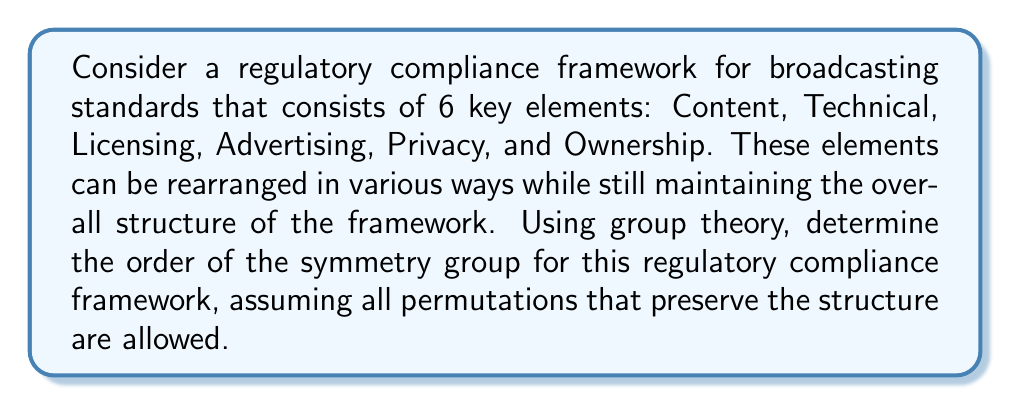Could you help me with this problem? To analyze the symmetry group of this regulatory compliance framework using group theory, we need to consider the permutations that preserve its structure. In this case, since all elements can be rearranged without changing the overall framework, we are dealing with the symmetric group on 6 elements, denoted as $S_6$.

The order of a symmetric group $S_n$ is given by $n!$, where $n$ is the number of elements being permuted. In this case, we have 6 elements, so:

1. Identify the number of elements: $n = 6$

2. Calculate the order of the symmetry group:
   $$|S_6| = 6!$$

3. Expand the factorial:
   $$6! = 6 \times 5 \times 4 \times 3 \times 2 \times 1$$

4. Compute the final result:
   $$6! = 720$$

Therefore, the order of the symmetry group for this regulatory compliance framework is 720. This means there are 720 distinct ways to permute the 6 elements while preserving the structure of the framework.

In the context of broadcasting regulations, this result implies that there are 720 ways to rearrange the key elements of the compliance framework. Each of these permutations represents a potentially valid restructuring of the regulatory priorities or focus areas, while still maintaining the overall integrity of the compliance system.
Answer: The order of the symmetry group for the regulatory compliance framework is 720. 